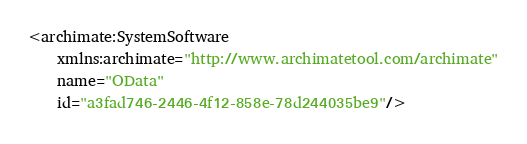Convert code to text. <code><loc_0><loc_0><loc_500><loc_500><_XML_><archimate:SystemSoftware
    xmlns:archimate="http://www.archimatetool.com/archimate"
    name="OData"
    id="a3fad746-2446-4f12-858e-78d244035be9"/>
</code> 